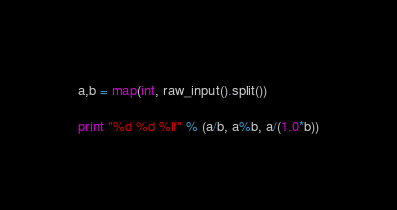<code> <loc_0><loc_0><loc_500><loc_500><_Python_>a,b = map(int, raw_input().split())

print "%d %d %lf" % (a/b, a%b, a/(1.0*b))</code> 